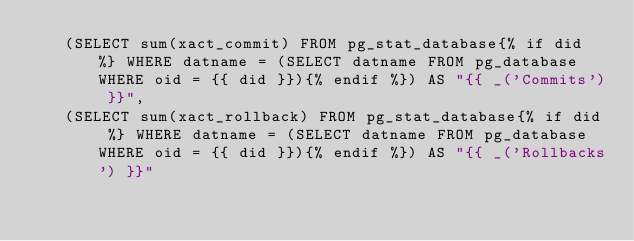<code> <loc_0><loc_0><loc_500><loc_500><_SQL_>   (SELECT sum(xact_commit) FROM pg_stat_database{% if did %} WHERE datname = (SELECT datname FROM pg_database WHERE oid = {{ did }}){% endif %}) AS "{{ _('Commits') }}",
   (SELECT sum(xact_rollback) FROM pg_stat_database{% if did %} WHERE datname = (SELECT datname FROM pg_database WHERE oid = {{ did }}){% endif %}) AS "{{ _('Rollbacks') }}"
</code> 